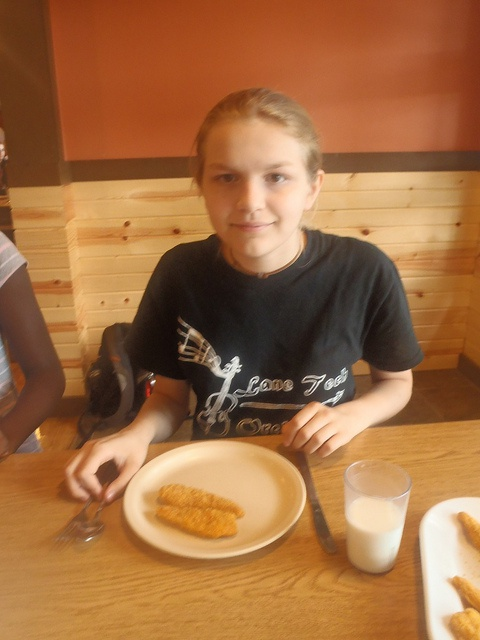Describe the objects in this image and their specific colors. I can see dining table in maroon, tan, red, and orange tones, people in maroon, black, brown, and tan tones, people in maroon, brown, darkgray, and gray tones, cup in maroon, tan, and beige tones, and backpack in maroon, black, and gray tones in this image. 